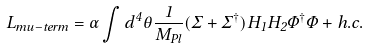<formula> <loc_0><loc_0><loc_500><loc_500>L _ { m u - t e r m } = \alpha \int d ^ { 4 } \theta \frac { 1 } { M _ { P l } } ( \Sigma + \Sigma ^ { \dagger } ) H _ { 1 } H _ { 2 } \Phi ^ { \dagger } \Phi + h . c .</formula> 